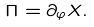<formula> <loc_0><loc_0><loc_500><loc_500>\Pi = \partial _ { \varphi } X .</formula> 